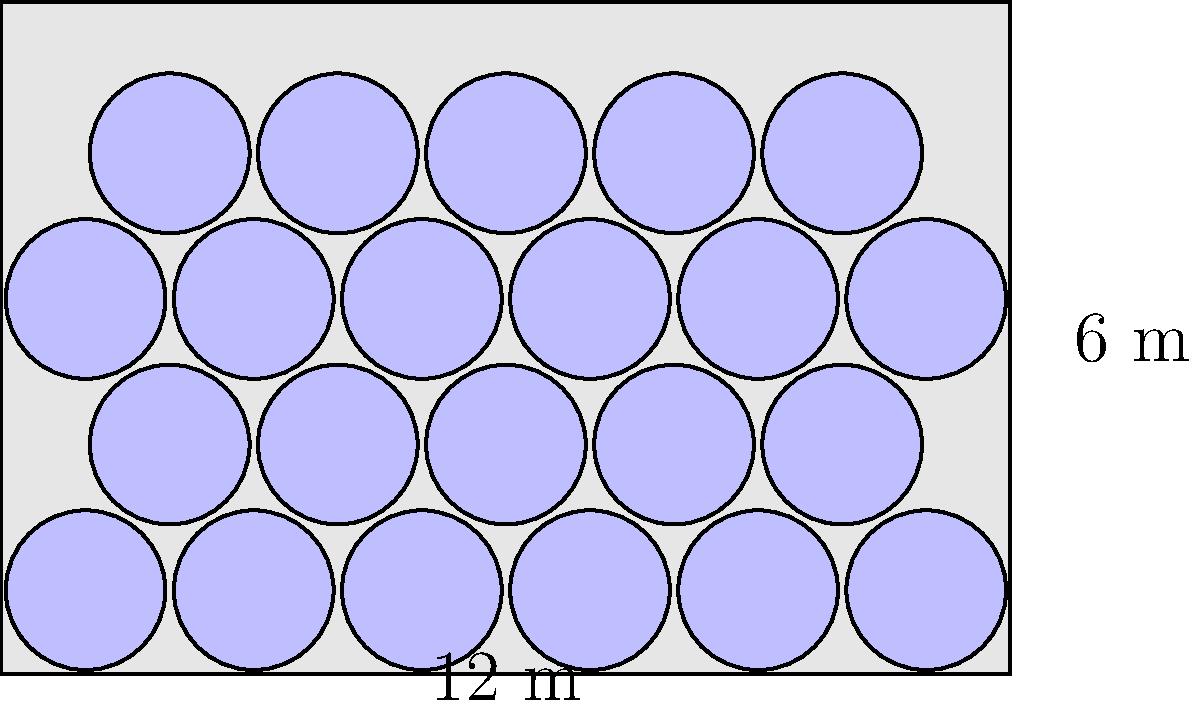As a brewmaster optimizing storage space, you're arranging circular kegs with a diameter of 2 meters in a rectangular storage area measuring 12 meters by 6 meters. What is the maximum number of kegs that can be stored using the hexagonal packing arrangement shown in the diagram? To determine the maximum number of kegs that can be stored, we'll follow these steps:

1. Identify the packing arrangement: The diagram shows a hexagonal close packing arrangement, which is the most efficient way to pack circles in a plane.

2. Calculate the number of rows:
   - The height of the storage area is 6 meters.
   - The vertical distance between keg centers is $2 \times \frac{\sqrt{3}}{2} = \sqrt{3}$ meters.
   - Number of rows = $\frac{6}{\sqrt{3}} \approx 3.46$
   - We can fit 4 rows (3 full rows and 1 partial row at the top).

3. Calculate the number of kegs in each row:
   - Even rows (1st and 3rd): 6 kegs (12 meters ÷ 2 meters per keg)
   - Odd rows (2nd and partial 4th): 5 kegs (centered between the kegs in even rows)

4. Sum up the total number of kegs:
   - 1st row: 6 kegs
   - 2nd row: 5 kegs
   - 3rd row: 6 kegs
   - 4th row (partial): 5 kegs

5. Total number of kegs: 6 + 5 + 6 + 5 = 22

Therefore, the maximum number of kegs that can be stored in this arrangement is 22.
Answer: 22 kegs 